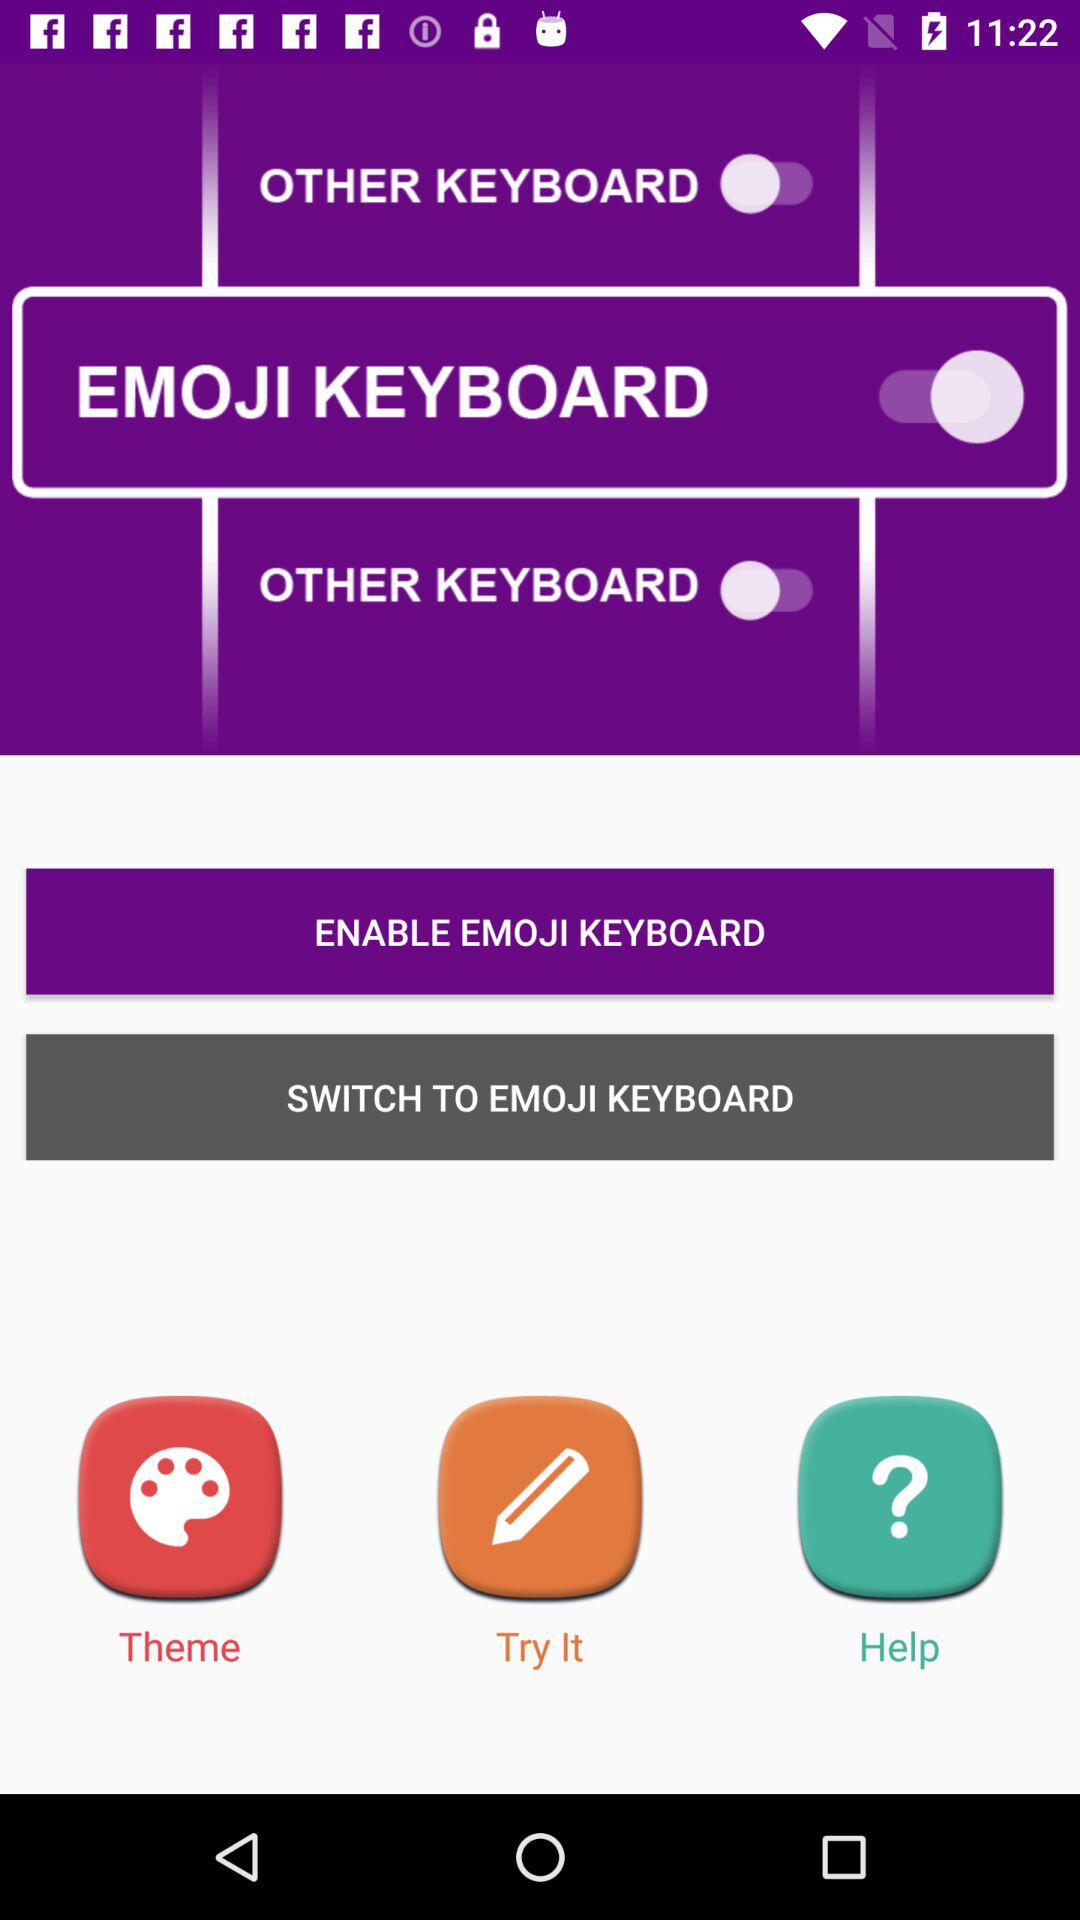What is the status of the "EMOJI KEYBOARD"? The status of the "EMOJI KEYBOARD" is "on". 